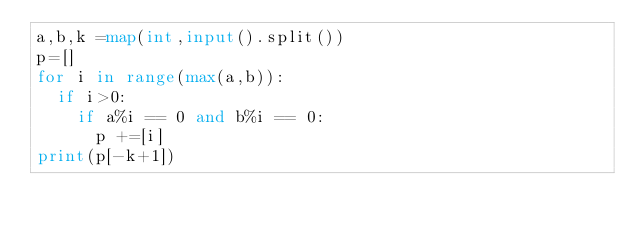<code> <loc_0><loc_0><loc_500><loc_500><_Python_>a,b,k =map(int,input().split())
p=[]
for i in range(max(a,b)):
  if i>0:
    if a%i == 0 and b%i == 0:
      p +=[i]
print(p[-k+1])</code> 